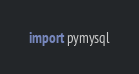<code> <loc_0><loc_0><loc_500><loc_500><_Python_>import pymysql
</code> 